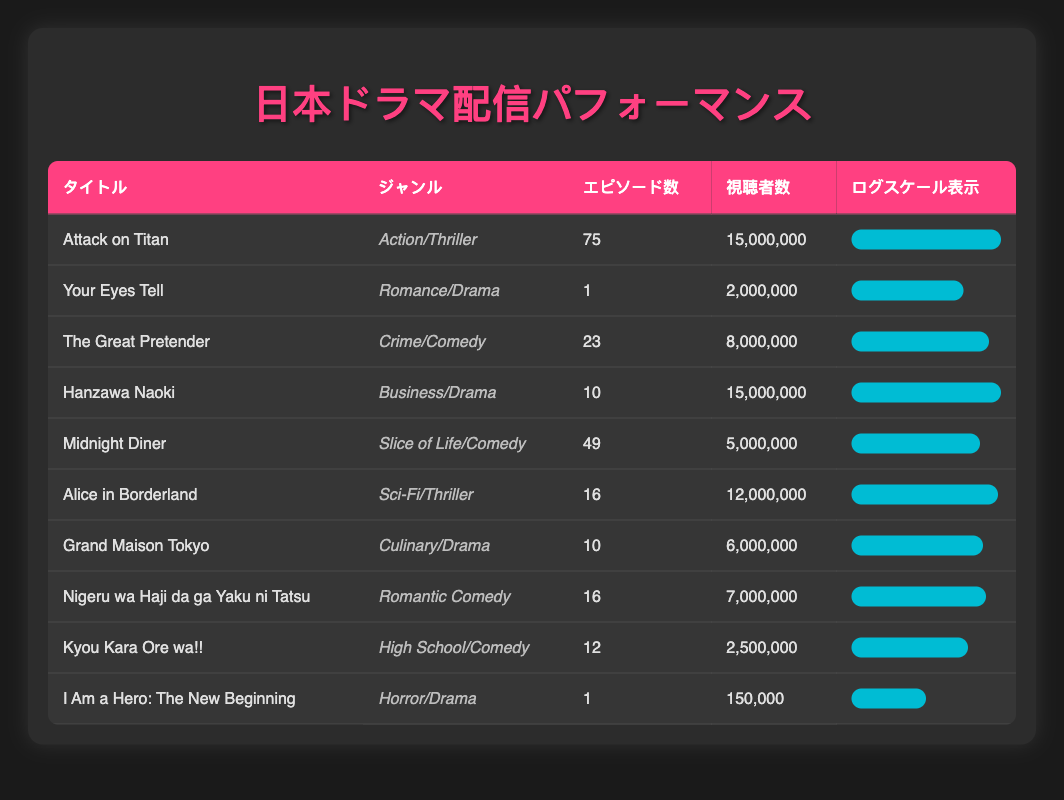What is the total viewership count for all dramas in the table? To find the total viewership count, add the viewership counts of all titles: 15000000 + 2000000 + 8000000 + 15000000 + 5000000 + 12000000 + 6000000 + 7000000 + 2500000 + 150000 = 40000000.
Answer: 40000000 Which drama has the highest number of episodes? By examining the Episodes column, "Attack on Titan" has 75 episodes, which is more than any other title in the table.
Answer: Attack on Titan Are there any dramas with only one episode? The data reveals that "Your Eyes Tell" and "I Am a Hero: The New Beginning" both have just 1 episode, confirming the presence of dramas with only one episode.
Answer: Yes What is the average viewership count of dramas in the Romance/Drama genre? There is only one drama in this genre: "Your Eyes Tell," with a viewership count of 2000000. As there is only one data point, the average is 2000000/1 = 2000000.
Answer: 2000000 How many genres have a viewership count greater than 10 million? The genres with viewership counts greater than 10 million are "Action/Thriller" (15,000,000), "Business/Drama" (15,000,000), and "Sci-Fi/Thriller" (12,000,000). This results in three genres.
Answer: 3 What is the difference in viewership count between the highest and lowest drama? The highest is "Attack on Titan" with 15000000 views and the lowest is "I Am a Hero: The New Beginning" with 150000 views, so the difference is 15000000 - 150000 = 14850000.
Answer: 14850000 Are there more comedies or dramas listed in the table? The table features three comedies: "The Great Pretender," "Midnight Diner," and "Kyou Kara Ore wa!!" and five dramas: "Your Eyes Tell," "Hanzawa Naoki," "Alice in Borderland," "Grand Maison Tokyo," and "I Am a Hero: The New Beginning." Thus, there are more dramas than comedies.
Answer: No Which genre has the most total episodes? The genre "Action/Thriller" (Attack on Titan) has the most episodes with 75, while "Romance/Drama" has 1, "Crime/Comedy" has 23, and all other genres have fewer than 75 episodes. Thus, "Action/Thriller" clearly has the most episodes.
Answer: Action/Thriller What is the average number of episodes for all dramas? The total number of episodes is 75 + 1 + 23 + 10 + 49 + 16 + 10 + 16 + 12 + 1 =  223. There are 10 dramas, so the average is 223/10 = 22.3.
Answer: 22.3 